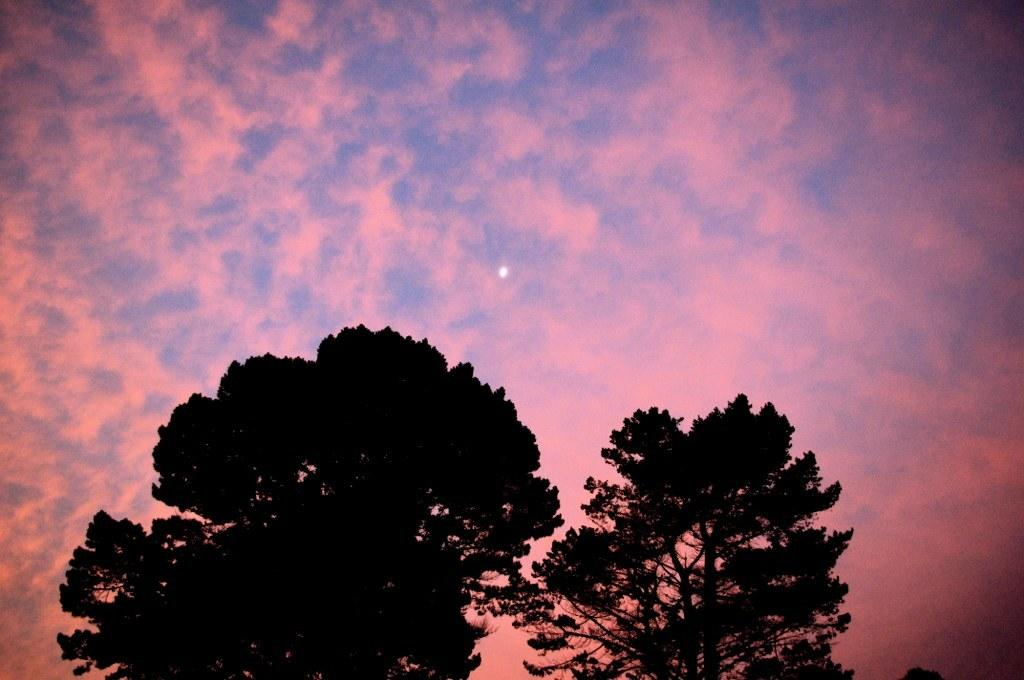What type of vegetation can be seen in the image? There are trees in the image. What is visible in the background of the image? The sky is visible in the image. What can be observed in the sky? Clouds are present in the sky. What arithmetic problem is being solved by the trees in the image? There is no arithmetic problem being solved by the trees in the image, as trees are living organisms and do not perform arithmetic. 